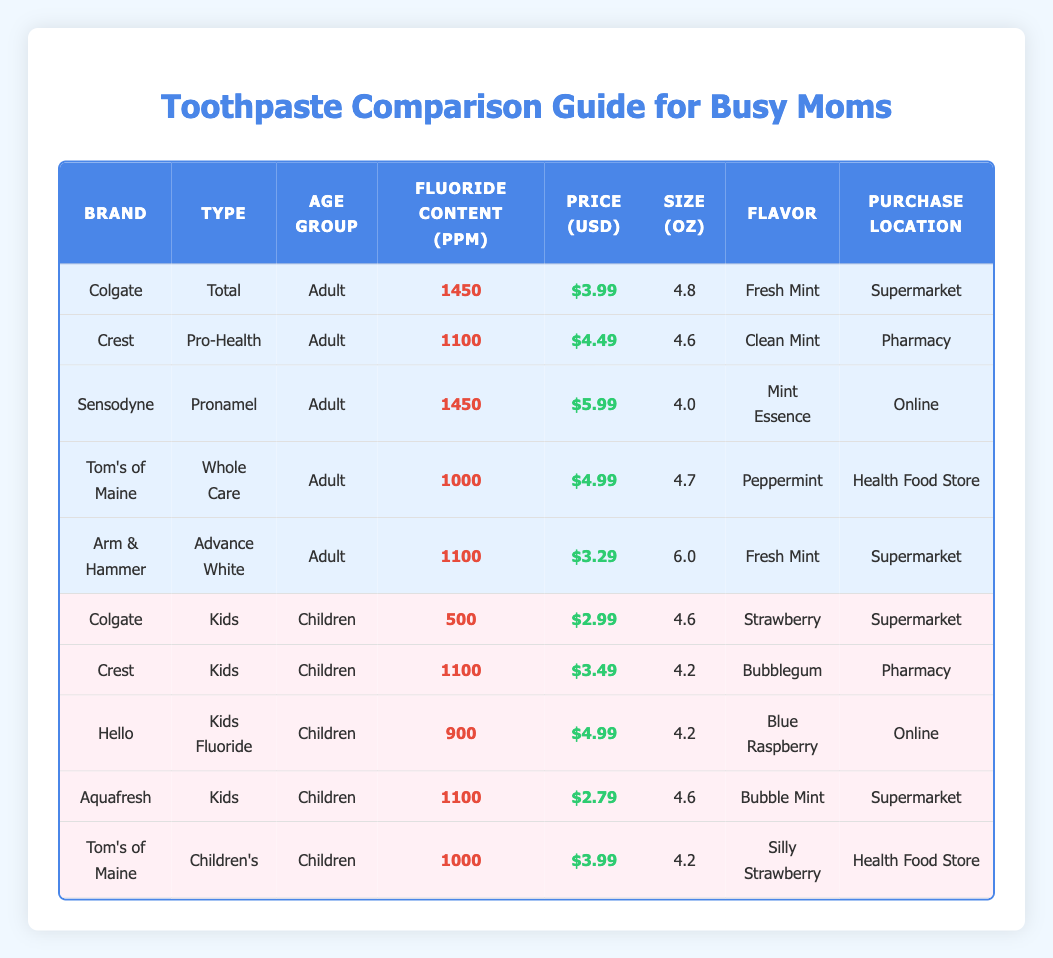What is the fluoride content of Colgate Total toothpaste? According to the table, the fluoride content for Colgate Total is listed as 1450 ppm.
Answer: 1450 ppm Which toothpaste brand has the lowest price? After comparing the prices of all brands, Aquafresh is the most affordable at $2.79.
Answer: Aquafresh What is the price difference between Sensodyne and Crest Pro-Health? The price of Sensodyne is $5.99, and Crest Pro-Health is $4.49. The difference is $5.99 - $4.49 = $1.50.
Answer: $1.50 Is there a toothpaste for children that has a fluoride content lower than 500 ppm? The table indicates that the lowest fluoride content in children's toothpaste is 500 ppm for Colgate Kids, meaning no toothpaste in the dataset is below that value.
Answer: No What is the average fluoride content of the kids' toothpaste brands? The fluoride content for kids' toothpaste is 500 (Colgate) + 1100 (Crest) + 900 (Hello) + 1100 (Aquafresh) + 1000 (Tom's of Maine) = 3700 ppm. There are 5 brands, so average = 3700/5 = 740 ppm.
Answer: 740 ppm How many different flavors are available in children's toothpaste? Looking at the table for children's toothpaste, the flavors are Strawberry, Bubblegum, Blue Raspberry, and Bubble Mint, which totals four distinct flavors.
Answer: 4 Does Tom's of Maine offer more than one type of toothpaste in the table? The table shows two entries for Tom's of Maine: one for "Whole Care" (Adult) and one for "Children's." Hence, Tom's of Maine does have more than one type.
Answer: Yes What is the price for the toothpaste that contains the highest fluoride content? Both Colgate Total and Sensodyne Pronamel contain the highest fluoride content of 1450 ppm. Their prices are $3.99 and $5.99 respectively. Sensodyne's price is higher at $5.99.
Answer: $5.99 Which brand appears to be the most affordable option for children who need a fluoride toothpaste? The brands for children's toothpaste include Colgate ($2.99), Crest ($3.49), Hello ($4.99), Aquafresh ($2.79), and Tom's of Maine ($3.99). The lowest price is Aquafresh at $2.79.
Answer: Aquafresh 